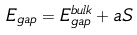<formula> <loc_0><loc_0><loc_500><loc_500>E _ { g a p } = E ^ { b u l k } _ { g a p } + a S</formula> 